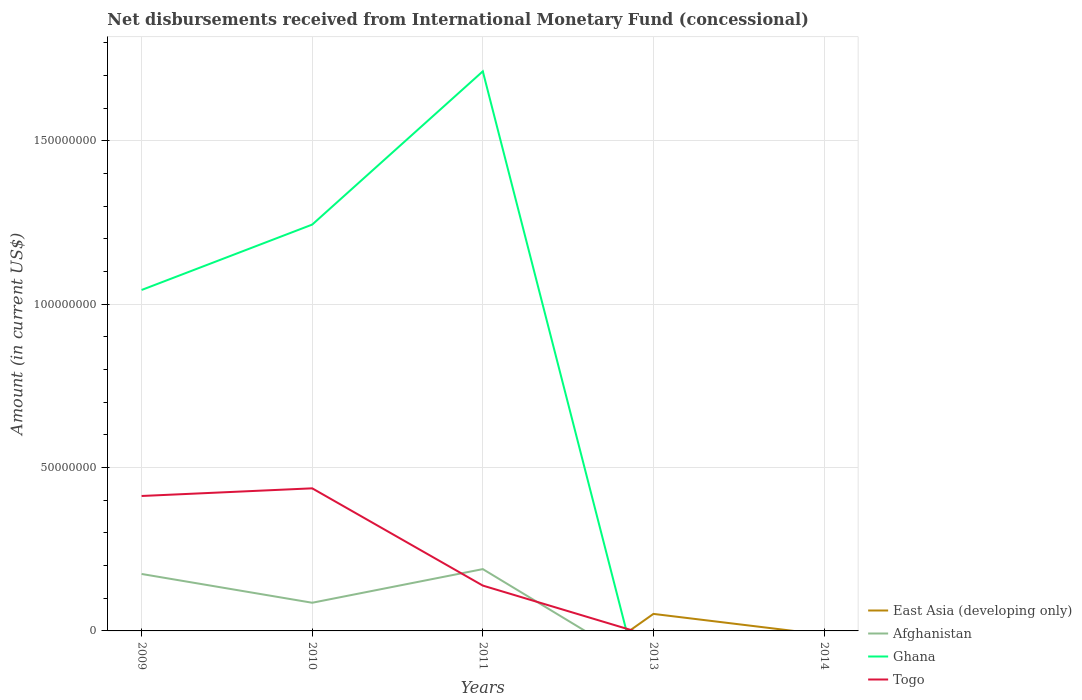Does the line corresponding to Afghanistan intersect with the line corresponding to Ghana?
Your response must be concise. Yes. Is the number of lines equal to the number of legend labels?
Ensure brevity in your answer.  No. Across all years, what is the maximum amount of disbursements received from International Monetary Fund in East Asia (developing only)?
Ensure brevity in your answer.  0. What is the total amount of disbursements received from International Monetary Fund in Ghana in the graph?
Your answer should be very brief. -2.00e+07. What is the difference between the highest and the second highest amount of disbursements received from International Monetary Fund in Togo?
Keep it short and to the point. 4.36e+07. What is the difference between the highest and the lowest amount of disbursements received from International Monetary Fund in East Asia (developing only)?
Make the answer very short. 1. Is the amount of disbursements received from International Monetary Fund in East Asia (developing only) strictly greater than the amount of disbursements received from International Monetary Fund in Ghana over the years?
Offer a terse response. No. How many years are there in the graph?
Offer a terse response. 5. What is the difference between two consecutive major ticks on the Y-axis?
Make the answer very short. 5.00e+07. Where does the legend appear in the graph?
Your answer should be compact. Bottom right. How many legend labels are there?
Keep it short and to the point. 4. How are the legend labels stacked?
Make the answer very short. Vertical. What is the title of the graph?
Keep it short and to the point. Net disbursements received from International Monetary Fund (concessional). What is the label or title of the X-axis?
Provide a succinct answer. Years. What is the label or title of the Y-axis?
Provide a short and direct response. Amount (in current US$). What is the Amount (in current US$) of East Asia (developing only) in 2009?
Ensure brevity in your answer.  0. What is the Amount (in current US$) of Afghanistan in 2009?
Offer a very short reply. 1.74e+07. What is the Amount (in current US$) in Ghana in 2009?
Give a very brief answer. 1.04e+08. What is the Amount (in current US$) of Togo in 2009?
Offer a very short reply. 4.13e+07. What is the Amount (in current US$) in Afghanistan in 2010?
Offer a very short reply. 8.62e+06. What is the Amount (in current US$) in Ghana in 2010?
Your answer should be compact. 1.24e+08. What is the Amount (in current US$) of Togo in 2010?
Offer a very short reply. 4.36e+07. What is the Amount (in current US$) in East Asia (developing only) in 2011?
Keep it short and to the point. 0. What is the Amount (in current US$) of Afghanistan in 2011?
Provide a short and direct response. 1.89e+07. What is the Amount (in current US$) of Ghana in 2011?
Keep it short and to the point. 1.71e+08. What is the Amount (in current US$) of Togo in 2011?
Make the answer very short. 1.39e+07. What is the Amount (in current US$) of East Asia (developing only) in 2013?
Offer a very short reply. 5.21e+06. What is the Amount (in current US$) of Togo in 2013?
Provide a succinct answer. 0. What is the Amount (in current US$) in Togo in 2014?
Offer a terse response. 0. Across all years, what is the maximum Amount (in current US$) in East Asia (developing only)?
Provide a succinct answer. 5.21e+06. Across all years, what is the maximum Amount (in current US$) of Afghanistan?
Offer a very short reply. 1.89e+07. Across all years, what is the maximum Amount (in current US$) of Ghana?
Offer a very short reply. 1.71e+08. Across all years, what is the maximum Amount (in current US$) in Togo?
Provide a short and direct response. 4.36e+07. Across all years, what is the minimum Amount (in current US$) in East Asia (developing only)?
Ensure brevity in your answer.  0. Across all years, what is the minimum Amount (in current US$) of Togo?
Give a very brief answer. 0. What is the total Amount (in current US$) in East Asia (developing only) in the graph?
Your answer should be compact. 5.21e+06. What is the total Amount (in current US$) of Afghanistan in the graph?
Provide a succinct answer. 4.50e+07. What is the total Amount (in current US$) of Ghana in the graph?
Your answer should be very brief. 4.00e+08. What is the total Amount (in current US$) of Togo in the graph?
Offer a very short reply. 9.88e+07. What is the difference between the Amount (in current US$) of Afghanistan in 2009 and that in 2010?
Offer a terse response. 8.81e+06. What is the difference between the Amount (in current US$) of Ghana in 2009 and that in 2010?
Provide a succinct answer. -2.00e+07. What is the difference between the Amount (in current US$) of Togo in 2009 and that in 2010?
Make the answer very short. -2.34e+06. What is the difference between the Amount (in current US$) in Afghanistan in 2009 and that in 2011?
Give a very brief answer. -1.49e+06. What is the difference between the Amount (in current US$) of Ghana in 2009 and that in 2011?
Provide a short and direct response. -6.69e+07. What is the difference between the Amount (in current US$) in Togo in 2009 and that in 2011?
Offer a very short reply. 2.74e+07. What is the difference between the Amount (in current US$) in Afghanistan in 2010 and that in 2011?
Ensure brevity in your answer.  -1.03e+07. What is the difference between the Amount (in current US$) in Ghana in 2010 and that in 2011?
Ensure brevity in your answer.  -4.69e+07. What is the difference between the Amount (in current US$) of Togo in 2010 and that in 2011?
Your answer should be very brief. 2.98e+07. What is the difference between the Amount (in current US$) of Afghanistan in 2009 and the Amount (in current US$) of Ghana in 2010?
Provide a short and direct response. -1.07e+08. What is the difference between the Amount (in current US$) in Afghanistan in 2009 and the Amount (in current US$) in Togo in 2010?
Provide a succinct answer. -2.62e+07. What is the difference between the Amount (in current US$) of Ghana in 2009 and the Amount (in current US$) of Togo in 2010?
Your answer should be compact. 6.07e+07. What is the difference between the Amount (in current US$) of Afghanistan in 2009 and the Amount (in current US$) of Ghana in 2011?
Your answer should be very brief. -1.54e+08. What is the difference between the Amount (in current US$) in Afghanistan in 2009 and the Amount (in current US$) in Togo in 2011?
Provide a short and direct response. 3.55e+06. What is the difference between the Amount (in current US$) of Ghana in 2009 and the Amount (in current US$) of Togo in 2011?
Ensure brevity in your answer.  9.05e+07. What is the difference between the Amount (in current US$) in Afghanistan in 2010 and the Amount (in current US$) in Ghana in 2011?
Provide a succinct answer. -1.63e+08. What is the difference between the Amount (in current US$) of Afghanistan in 2010 and the Amount (in current US$) of Togo in 2011?
Your answer should be compact. -5.25e+06. What is the difference between the Amount (in current US$) of Ghana in 2010 and the Amount (in current US$) of Togo in 2011?
Ensure brevity in your answer.  1.10e+08. What is the average Amount (in current US$) in East Asia (developing only) per year?
Provide a short and direct response. 1.04e+06. What is the average Amount (in current US$) in Afghanistan per year?
Your answer should be very brief. 8.99e+06. What is the average Amount (in current US$) of Ghana per year?
Your response must be concise. 8.00e+07. What is the average Amount (in current US$) in Togo per year?
Your answer should be compact. 1.98e+07. In the year 2009, what is the difference between the Amount (in current US$) of Afghanistan and Amount (in current US$) of Ghana?
Provide a short and direct response. -8.69e+07. In the year 2009, what is the difference between the Amount (in current US$) in Afghanistan and Amount (in current US$) in Togo?
Give a very brief answer. -2.39e+07. In the year 2009, what is the difference between the Amount (in current US$) in Ghana and Amount (in current US$) in Togo?
Provide a succinct answer. 6.30e+07. In the year 2010, what is the difference between the Amount (in current US$) in Afghanistan and Amount (in current US$) in Ghana?
Your response must be concise. -1.16e+08. In the year 2010, what is the difference between the Amount (in current US$) in Afghanistan and Amount (in current US$) in Togo?
Provide a succinct answer. -3.50e+07. In the year 2010, what is the difference between the Amount (in current US$) of Ghana and Amount (in current US$) of Togo?
Make the answer very short. 8.07e+07. In the year 2011, what is the difference between the Amount (in current US$) of Afghanistan and Amount (in current US$) of Ghana?
Offer a very short reply. -1.52e+08. In the year 2011, what is the difference between the Amount (in current US$) of Afghanistan and Amount (in current US$) of Togo?
Ensure brevity in your answer.  5.04e+06. In the year 2011, what is the difference between the Amount (in current US$) in Ghana and Amount (in current US$) in Togo?
Make the answer very short. 1.57e+08. What is the ratio of the Amount (in current US$) in Afghanistan in 2009 to that in 2010?
Offer a terse response. 2.02. What is the ratio of the Amount (in current US$) in Ghana in 2009 to that in 2010?
Keep it short and to the point. 0.84. What is the ratio of the Amount (in current US$) of Togo in 2009 to that in 2010?
Provide a short and direct response. 0.95. What is the ratio of the Amount (in current US$) in Afghanistan in 2009 to that in 2011?
Your response must be concise. 0.92. What is the ratio of the Amount (in current US$) in Ghana in 2009 to that in 2011?
Provide a succinct answer. 0.61. What is the ratio of the Amount (in current US$) of Togo in 2009 to that in 2011?
Give a very brief answer. 2.98. What is the ratio of the Amount (in current US$) of Afghanistan in 2010 to that in 2011?
Your answer should be very brief. 0.46. What is the ratio of the Amount (in current US$) of Ghana in 2010 to that in 2011?
Your response must be concise. 0.73. What is the ratio of the Amount (in current US$) of Togo in 2010 to that in 2011?
Your response must be concise. 3.15. What is the difference between the highest and the second highest Amount (in current US$) in Afghanistan?
Your answer should be very brief. 1.49e+06. What is the difference between the highest and the second highest Amount (in current US$) of Ghana?
Ensure brevity in your answer.  4.69e+07. What is the difference between the highest and the second highest Amount (in current US$) of Togo?
Ensure brevity in your answer.  2.34e+06. What is the difference between the highest and the lowest Amount (in current US$) in East Asia (developing only)?
Give a very brief answer. 5.21e+06. What is the difference between the highest and the lowest Amount (in current US$) in Afghanistan?
Make the answer very short. 1.89e+07. What is the difference between the highest and the lowest Amount (in current US$) in Ghana?
Your answer should be very brief. 1.71e+08. What is the difference between the highest and the lowest Amount (in current US$) in Togo?
Your answer should be compact. 4.36e+07. 